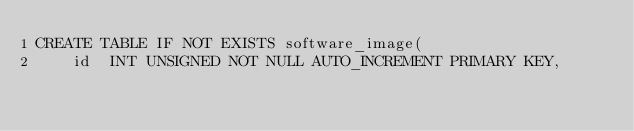Convert code to text. <code><loc_0><loc_0><loc_500><loc_500><_SQL_>CREATE TABLE IF NOT EXISTS software_image(
    id  INT UNSIGNED NOT NULL AUTO_INCREMENT PRIMARY KEY,</code> 